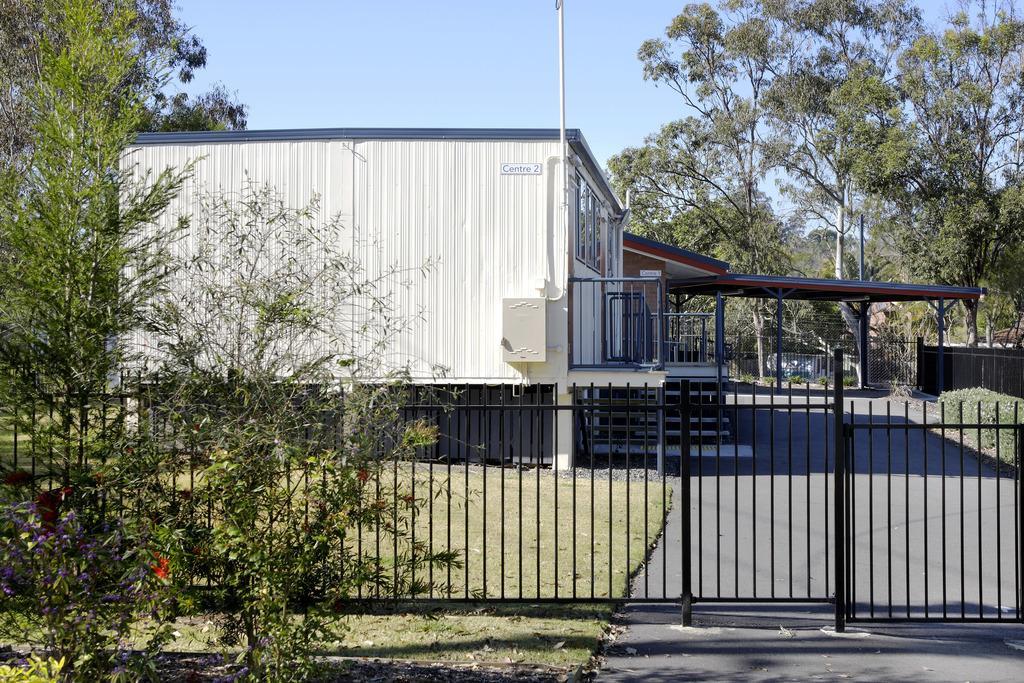In one or two sentences, can you explain what this image depicts? In this image I can see a white color house, poles, trees and the grass. In the background I can see the sky. 